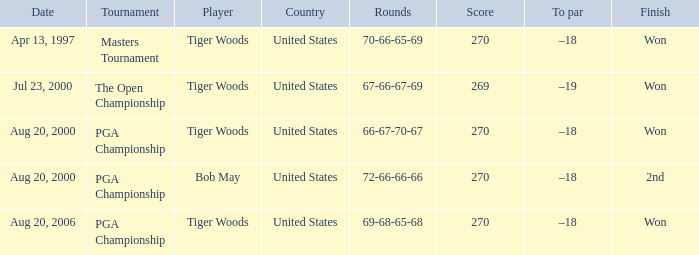Which days involved the recording of rounds with 66, 67, 70, and 67 outcomes? Aug 20, 2000. 